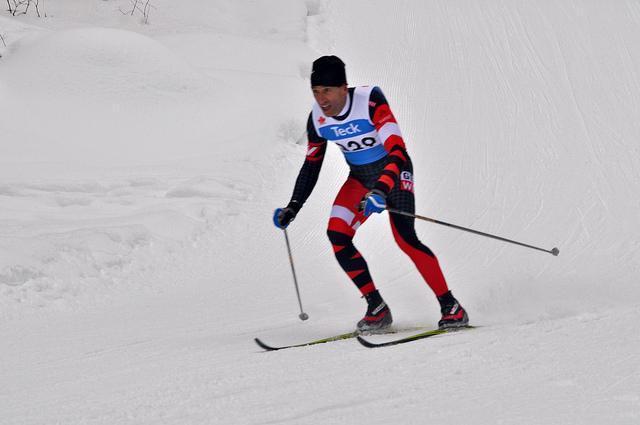How many people can you see?
Give a very brief answer. 1. How many cars are visible?
Give a very brief answer. 0. 